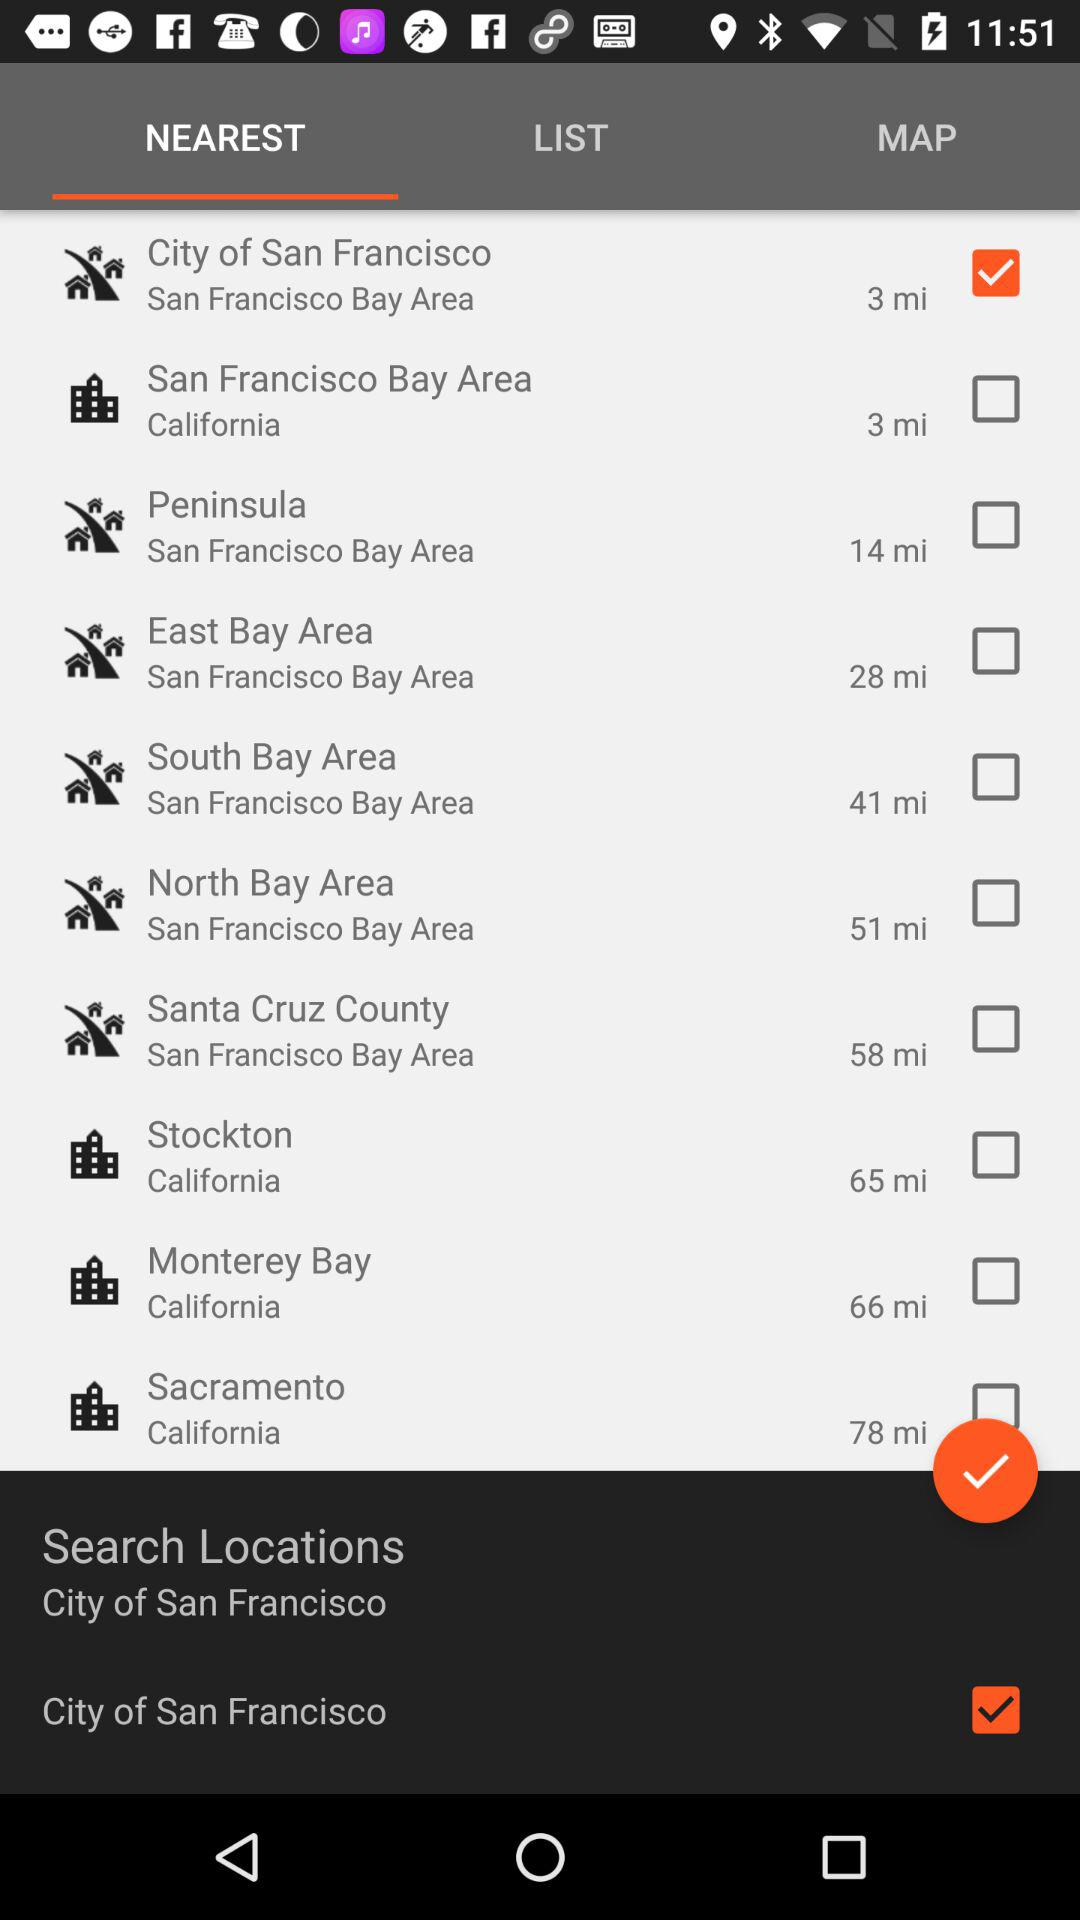How many miles is the farthest location from City of San Francisco?
Answer the question using a single word or phrase. 78 